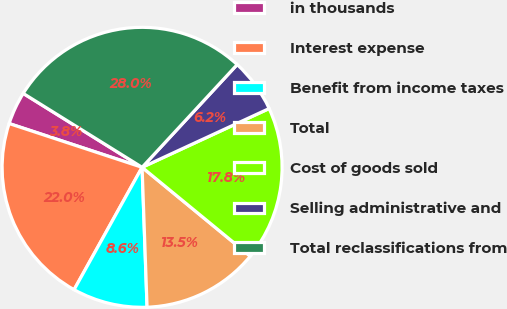<chart> <loc_0><loc_0><loc_500><loc_500><pie_chart><fcel>in thousands<fcel>Interest expense<fcel>Benefit from income taxes<fcel>Total<fcel>Cost of goods sold<fcel>Selling administrative and<fcel>Total reclassifications from<nl><fcel>3.79%<fcel>21.99%<fcel>8.64%<fcel>13.49%<fcel>17.84%<fcel>6.22%<fcel>28.03%<nl></chart> 